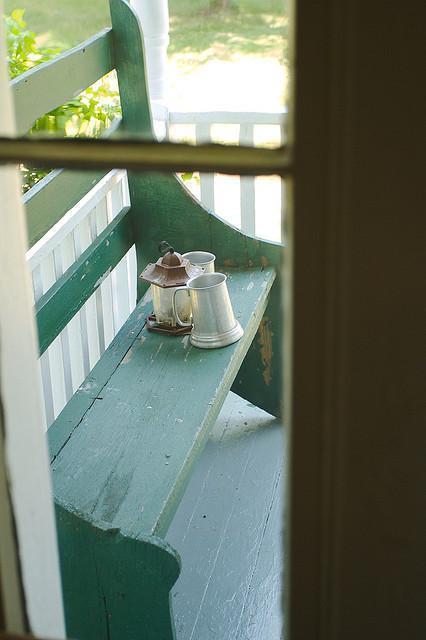What type of drinking vessels are on the bench?
Make your selection and explain in format: 'Answer: answer
Rationale: rationale.'
Options: Steins, teacups, lowball, espresso cups. Answer: steins.
Rationale: Steins are on the bench. 